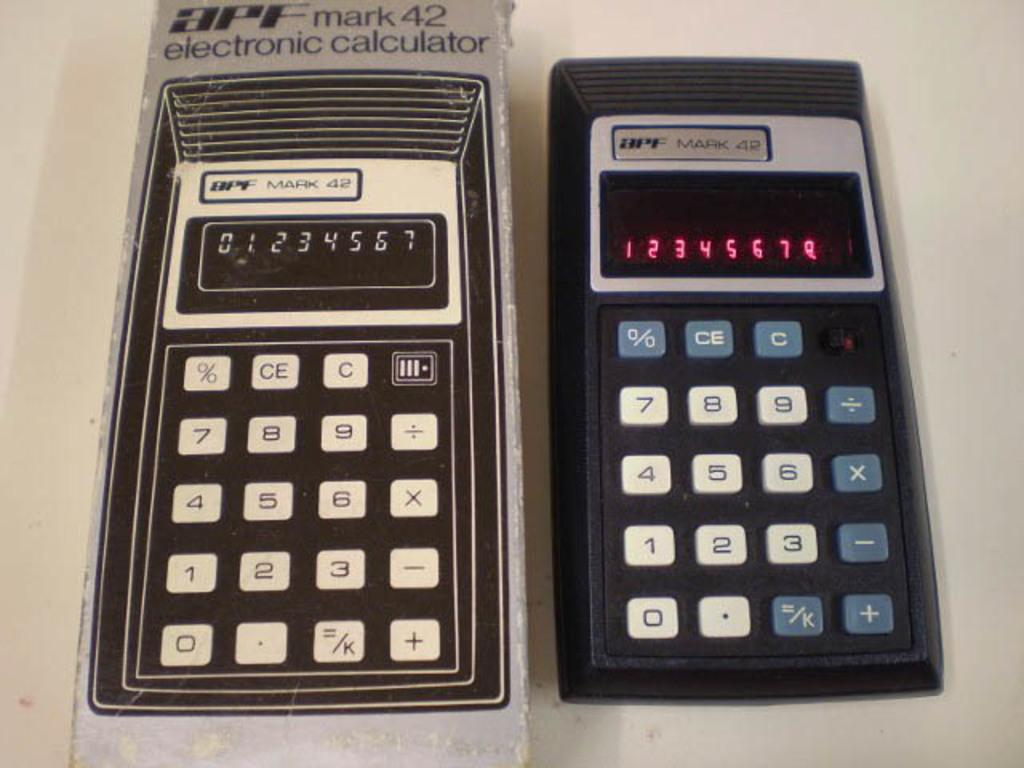<image>
Create a compact narrative representing the image presented. An old APF calculator has the numbers 01234567 written on the display screen 